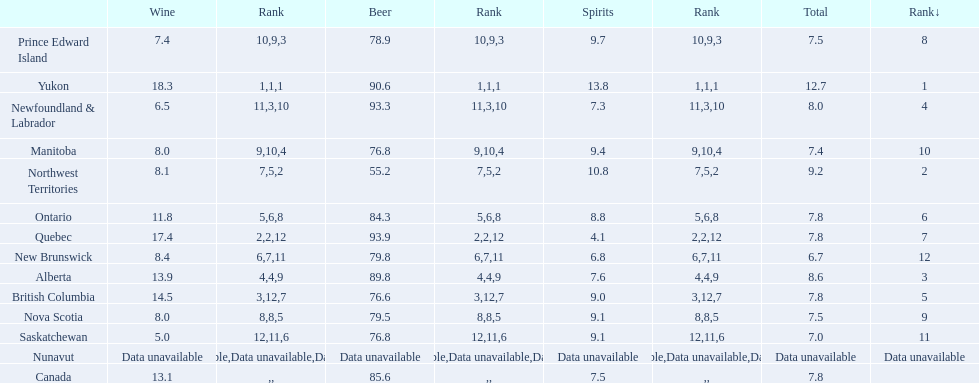Which province consumes the least amount of spirits? Quebec. 